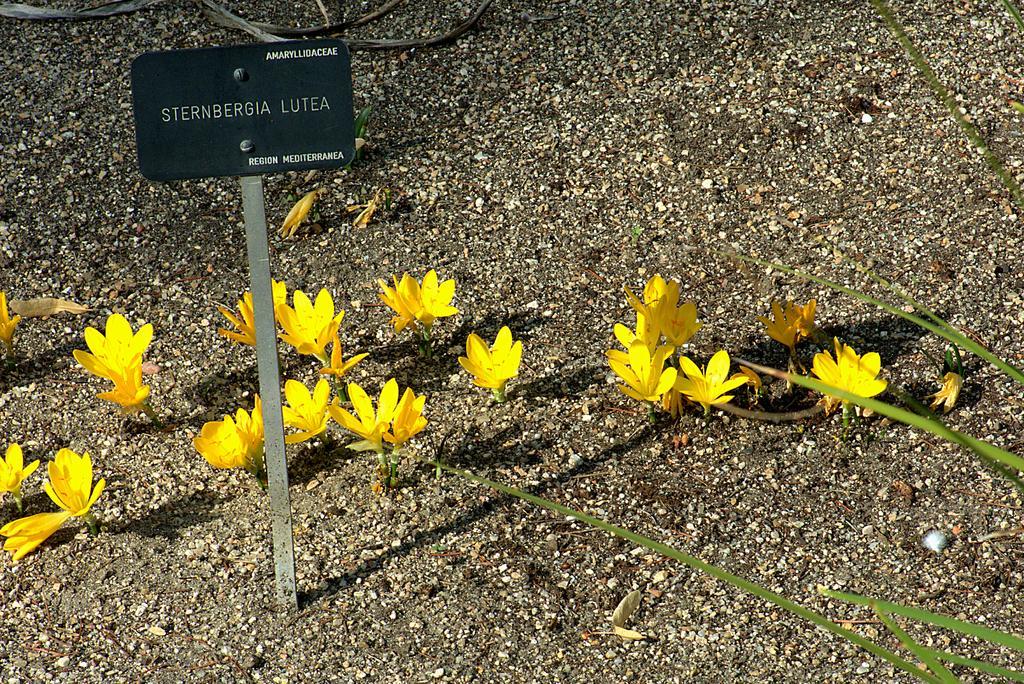In one or two sentences, can you explain what this image depicts? In the picture i can see a board there are some flowers which are in yellow color and there is soil. 